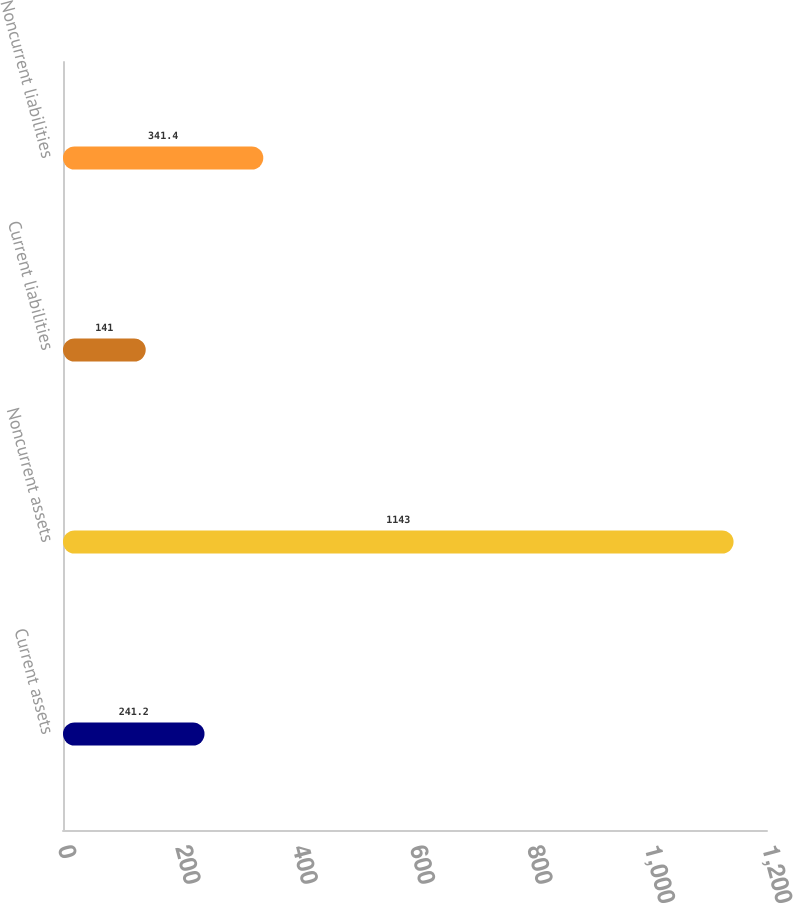Convert chart to OTSL. <chart><loc_0><loc_0><loc_500><loc_500><bar_chart><fcel>Current assets<fcel>Noncurrent assets<fcel>Current liabilities<fcel>Noncurrent liabilities<nl><fcel>241.2<fcel>1143<fcel>141<fcel>341.4<nl></chart> 